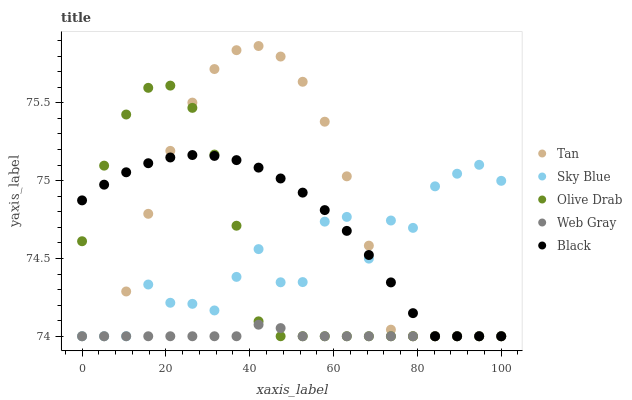Does Web Gray have the minimum area under the curve?
Answer yes or no. Yes. Does Tan have the maximum area under the curve?
Answer yes or no. Yes. Does Tan have the minimum area under the curve?
Answer yes or no. No. Does Web Gray have the maximum area under the curve?
Answer yes or no. No. Is Web Gray the smoothest?
Answer yes or no. Yes. Is Sky Blue the roughest?
Answer yes or no. Yes. Is Tan the smoothest?
Answer yes or no. No. Is Tan the roughest?
Answer yes or no. No. Does Sky Blue have the lowest value?
Answer yes or no. Yes. Does Tan have the highest value?
Answer yes or no. Yes. Does Web Gray have the highest value?
Answer yes or no. No. Does Web Gray intersect Olive Drab?
Answer yes or no. Yes. Is Web Gray less than Olive Drab?
Answer yes or no. No. Is Web Gray greater than Olive Drab?
Answer yes or no. No. 